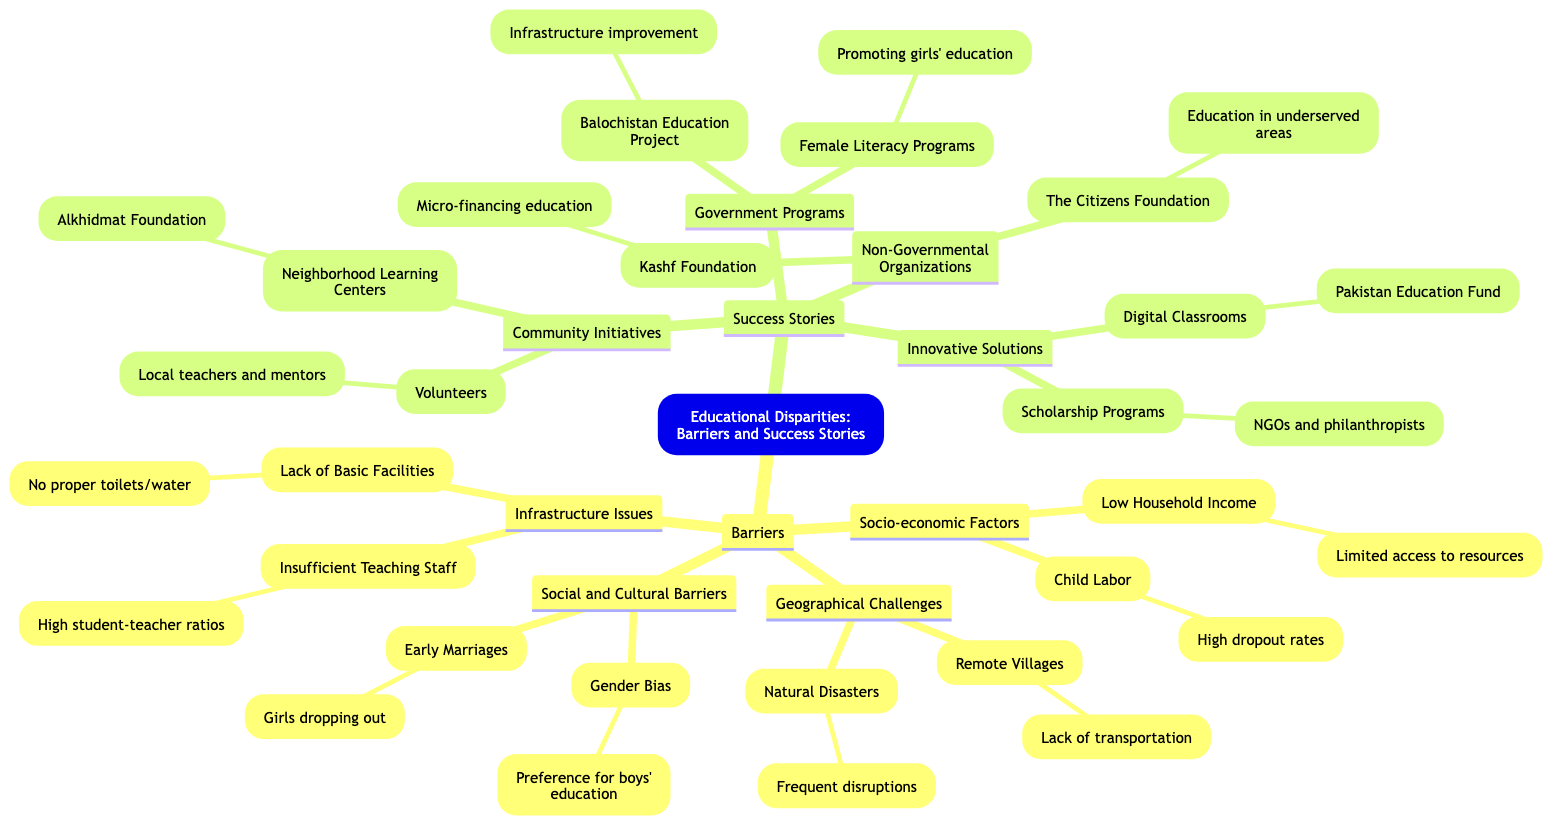What are the four main barriers listed in the diagram? The diagram categorizes barriers into four main groups: Socio-economic Factors, Geographical Challenges, Social and Cultural Barriers, and Infrastructure Issues. These groups are directly stated in the main branches of the mind map.
Answer: Socio-economic Factors, Geographical Challenges, Social and Cultural Barriers, Infrastructure Issues Which barrier is associated with limited access to educational resources? The mind map states that "Low Household Income" under Socio-economic Factors is associated with "Limited access to educational resources." This relationship is shown in the sub-branch connected to the "Low Household Income" node.
Answer: Low Household Income How many success stories are listed in the diagram? There are four main categories of success stories mentioned: Community Initiatives, Government Programs, Non-Governmental Organizations, and Innovative Solutions. Each of these categories serves as a main branch under the Success Stories section.
Answer: 4 Which organization is mentioned for promoting girls' education? The mind map lists "Female Literacy Programs" under Government Programs as an initiative aimed at promoting girls' education, which is indicated in its connection to that category.
Answer: Female Literacy Programs What is one reason cited for high dropout rates among children? The diagram specifies "Child Labor" under Socio-economic Factors, which is directly associated with "High dropout rates among children." This relationship can be traced through the nodes connecting these two pieces of information.
Answer: Child Labor Which community initiative is highlighted in the success stories? The community initiative listed in the mind map is "Neighborhood Learning Centers," which is connected to a specific example - Alkhidmat Foundation Learning Center. This information is explicitly shown under the Community Initiatives section.
Answer: Neighborhood Learning Centers What geographical challenge is linked to frequent disruptions in education? The mind map connects "Natural Disasters" under Geographical Challenges with the phrase "Frequent disruptions in education," illustrating how geographical factors affect schooling through this linkage.
Answer: Natural Disasters How does "Kashf Foundation" support education? The mind map indicates that "Kashf Foundation" provides "Micro-financing education for low-income families," detailing the organization’s role in enhancing access to education through financial support. This relationship is visually represented in the Non-Governmental Organizations branch.
Answer: Micro-financing education Which innovative solution is mentioned for enabling remote learning? The mind map mentions "Digital Classrooms" under Innovative Solutions as an initiative facilitating remote learning, specifically citing the Pakistan Education Fund as a related example. This information is clearly outlined in the relevant section of the diagram.
Answer: Digital Classrooms 